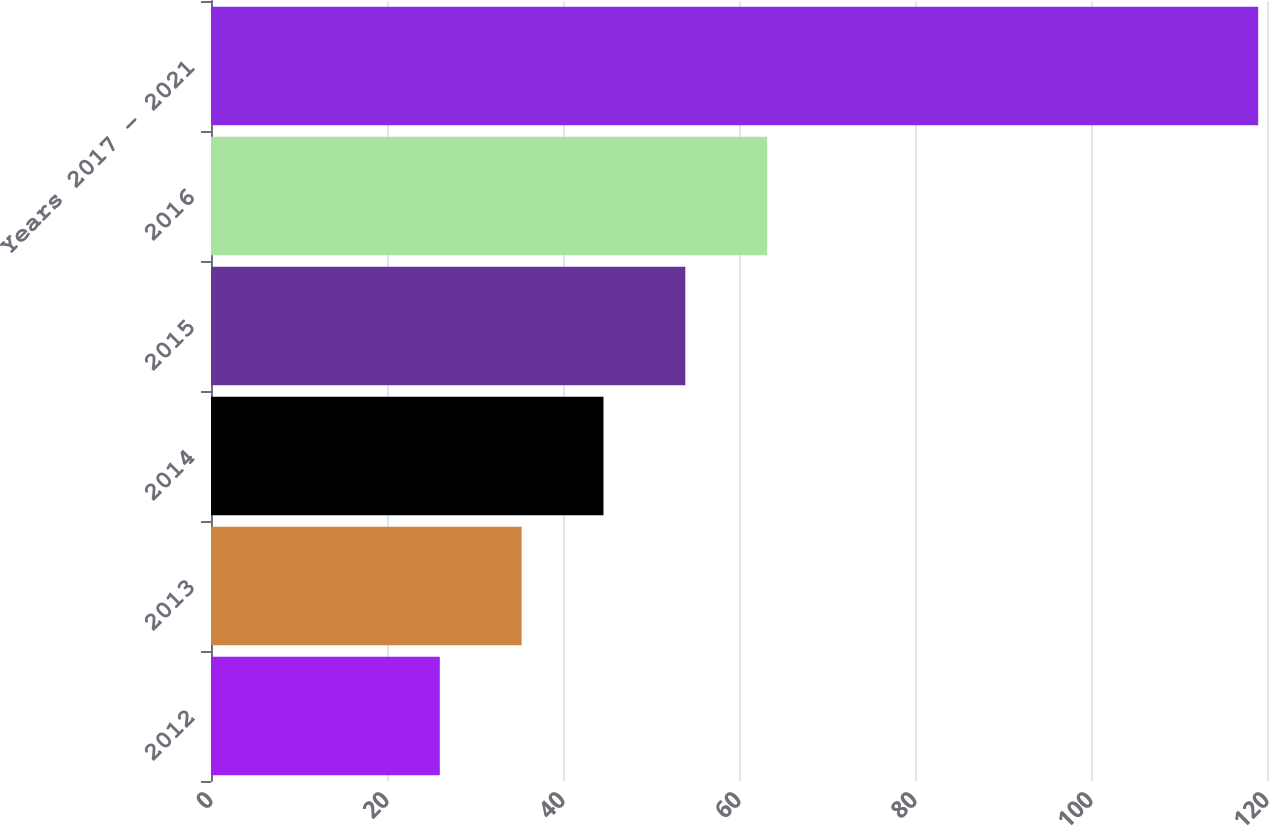<chart> <loc_0><loc_0><loc_500><loc_500><bar_chart><fcel>2012<fcel>2013<fcel>2014<fcel>2015<fcel>2016<fcel>Years 2017 - 2021<nl><fcel>26<fcel>35.3<fcel>44.6<fcel>53.9<fcel>63.2<fcel>119<nl></chart> 